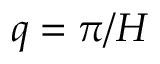<formula> <loc_0><loc_0><loc_500><loc_500>q = \pi / H</formula> 